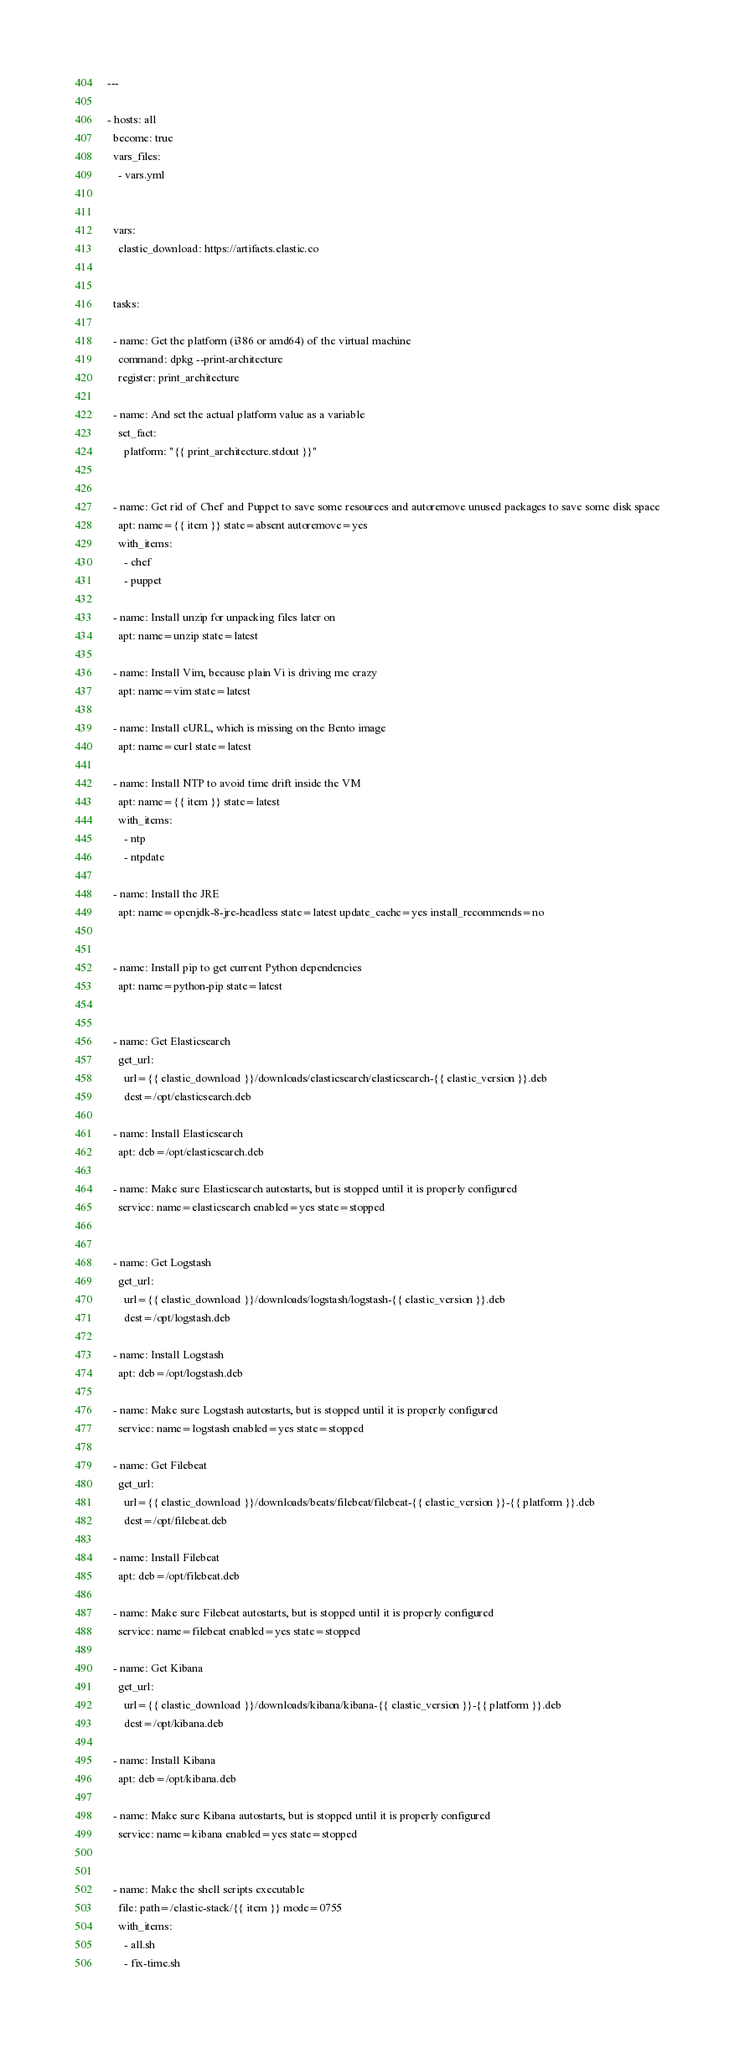Convert code to text. <code><loc_0><loc_0><loc_500><loc_500><_YAML_>---

- hosts: all
  become: true
  vars_files:
    - vars.yml


  vars:
    elastic_download: https://artifacts.elastic.co


  tasks:

  - name: Get the platform (i386 or amd64) of the virtual machine
    command: dpkg --print-architecture
    register: print_architecture

  - name: And set the actual platform value as a variable
    set_fact:
      platform: "{{ print_architecture.stdout }}"


  - name: Get rid of Chef and Puppet to save some resources and autoremove unused packages to save some disk space
    apt: name={{ item }} state=absent autoremove=yes
    with_items:
      - chef
      - puppet

  - name: Install unzip for unpacking files later on
    apt: name=unzip state=latest

  - name: Install Vim, because plain Vi is driving me crazy
    apt: name=vim state=latest

  - name: Install cURL, which is missing on the Bento image
    apt: name=curl state=latest

  - name: Install NTP to avoid time drift inside the VM
    apt: name={{ item }} state=latest
    with_items:
      - ntp
      - ntpdate

  - name: Install the JRE
    apt: name=openjdk-8-jre-headless state=latest update_cache=yes install_recommends=no


  - name: Install pip to get current Python dependencies
    apt: name=python-pip state=latest


  - name: Get Elasticsearch
    get_url:
      url={{ elastic_download }}/downloads/elasticsearch/elasticsearch-{{ elastic_version }}.deb
      dest=/opt/elasticsearch.deb

  - name: Install Elasticsearch
    apt: deb=/opt/elasticsearch.deb

  - name: Make sure Elasticsearch autostarts, but is stopped until it is properly configured
    service: name=elasticsearch enabled=yes state=stopped


  - name: Get Logstash
    get_url:
      url={{ elastic_download }}/downloads/logstash/logstash-{{ elastic_version }}.deb
      dest=/opt/logstash.deb

  - name: Install Logstash
    apt: deb=/opt/logstash.deb

  - name: Make sure Logstash autostarts, but is stopped until it is properly configured
    service: name=logstash enabled=yes state=stopped

  - name: Get Filebeat
    get_url:
      url={{ elastic_download }}/downloads/beats/filebeat/filebeat-{{ elastic_version }}-{{ platform }}.deb
      dest=/opt/filebeat.deb

  - name: Install Filebeat
    apt: deb=/opt/filebeat.deb

  - name: Make sure Filebeat autostarts, but is stopped until it is properly configured
    service: name=filebeat enabled=yes state=stopped

  - name: Get Kibana
    get_url:
      url={{ elastic_download }}/downloads/kibana/kibana-{{ elastic_version }}-{{ platform }}.deb
      dest=/opt/kibana.deb

  - name: Install Kibana
    apt: deb=/opt/kibana.deb

  - name: Make sure Kibana autostarts, but is stopped until it is properly configured
    service: name=kibana enabled=yes state=stopped


  - name: Make the shell scripts executable
    file: path=/elastic-stack/{{ item }} mode=0755
    with_items:
      - all.sh
      - fix-time.sh

</code> 